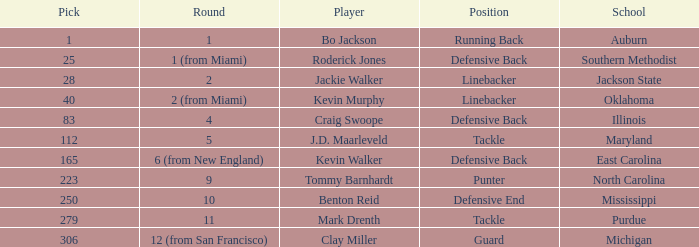What academy did bo jackson enroll in? Auburn. 